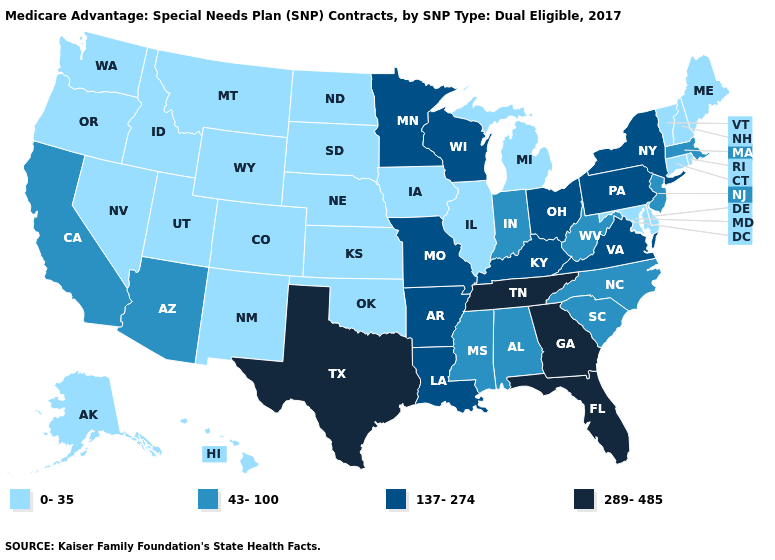What is the value of California?
Quick response, please. 43-100. What is the value of Wisconsin?
Be succinct. 137-274. Does the first symbol in the legend represent the smallest category?
Answer briefly. Yes. What is the highest value in states that border Connecticut?
Answer briefly. 137-274. What is the value of Illinois?
Quick response, please. 0-35. What is the value of New Jersey?
Give a very brief answer. 43-100. Does Oklahoma have the lowest value in the USA?
Give a very brief answer. Yes. Does Arizona have the lowest value in the West?
Keep it brief. No. Among the states that border Florida , which have the highest value?
Quick response, please. Georgia. Does California have a lower value than Wyoming?
Quick response, please. No. Which states hav the highest value in the West?
Answer briefly. Arizona, California. Does Michigan have the highest value in the USA?
Concise answer only. No. Which states hav the highest value in the West?
Be succinct. Arizona, California. Which states have the highest value in the USA?
Give a very brief answer. Florida, Georgia, Tennessee, Texas. Among the states that border Missouri , which have the lowest value?
Keep it brief. Iowa, Illinois, Kansas, Nebraska, Oklahoma. 